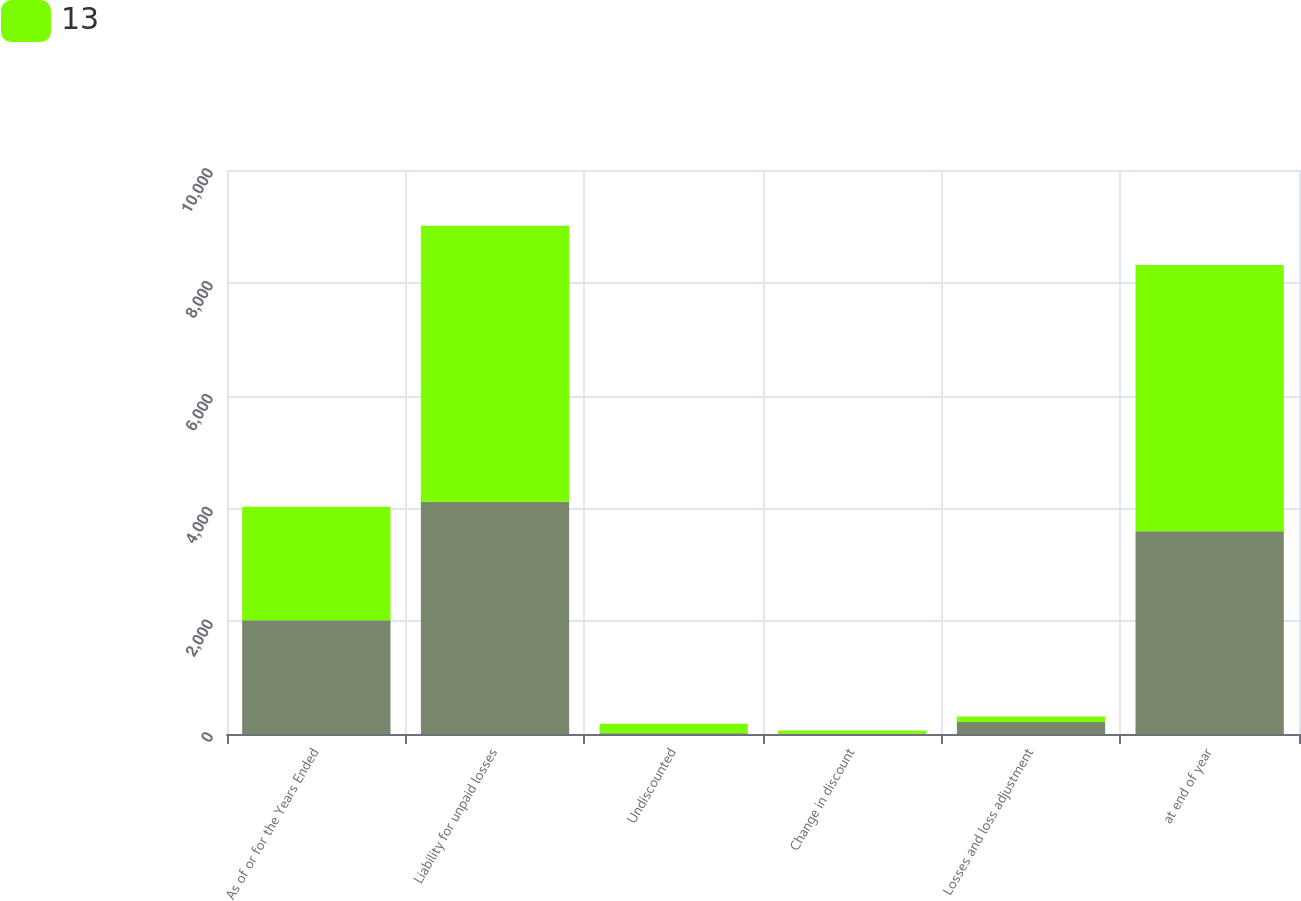Convert chart. <chart><loc_0><loc_0><loc_500><loc_500><stacked_bar_chart><ecel><fcel>As of or for the Years Ended<fcel>Liability for unpaid losses<fcel>Undiscounted<fcel>Change in discount<fcel>Losses and loss adjustment<fcel>at end of year<nl><fcel>nan<fcel>2015<fcel>4117<fcel>13<fcel>9<fcel>214<fcel>3595<nl><fcel>13<fcel>2013<fcel>4896<fcel>169<fcel>51<fcel>98<fcel>4720<nl></chart> 